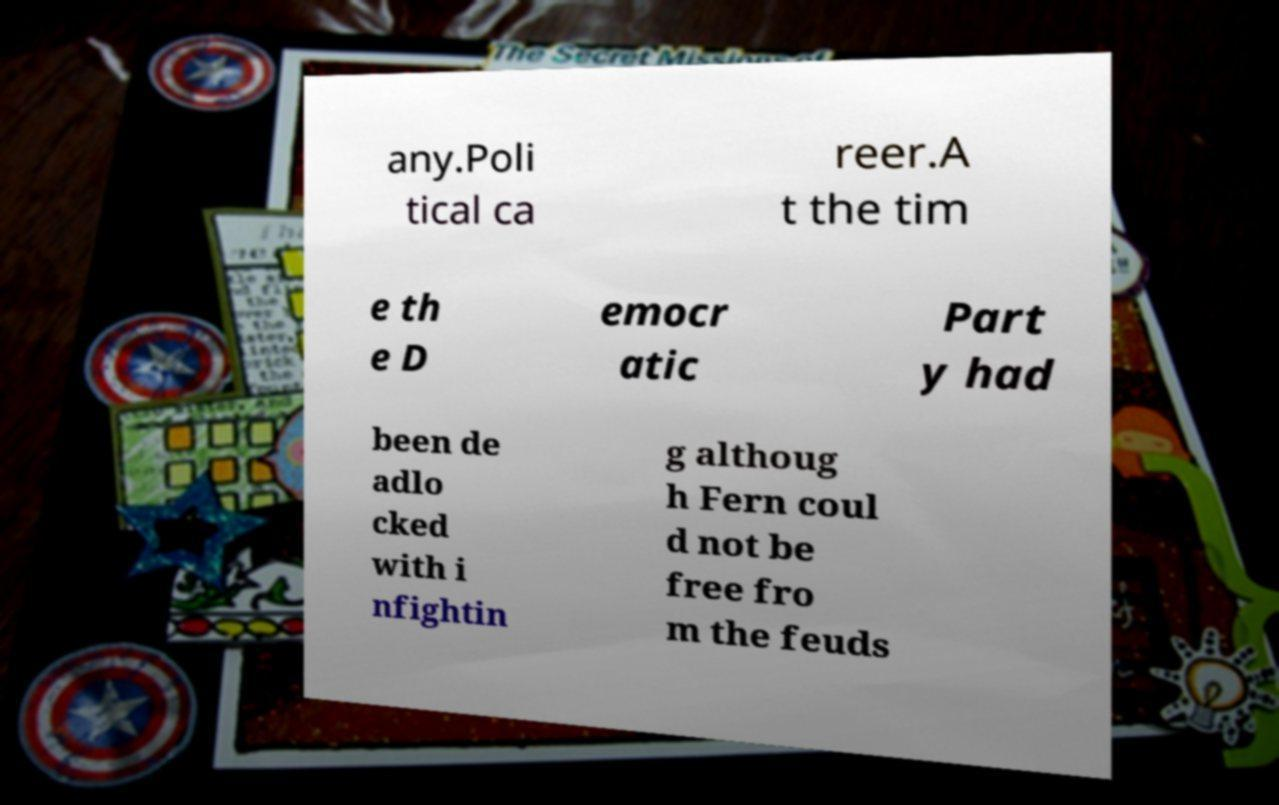Can you accurately transcribe the text from the provided image for me? any.Poli tical ca reer.A t the tim e th e D emocr atic Part y had been de adlo cked with i nfightin g althoug h Fern coul d not be free fro m the feuds 